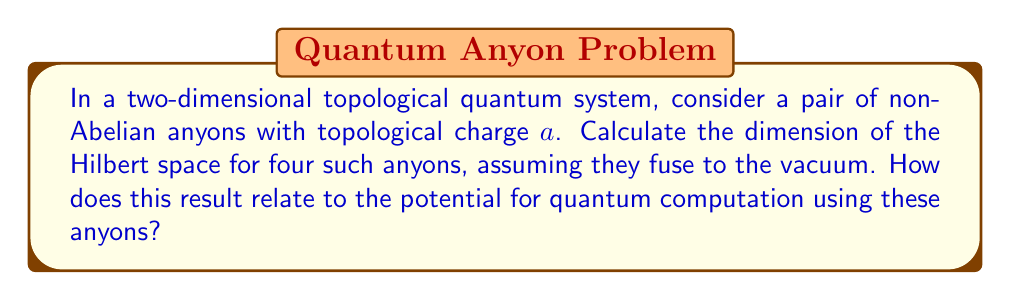Give your solution to this math problem. To solve this problem, we need to follow these steps:

1) First, recall that for non-Abelian anyons, the fusion outcome is not unique. For anyons with topological charge $a$, the fusion rules can be represented as:

   $$ a \times a = I + \psi $$

   where $I$ is the vacuum (trivial charge) and $\psi$ is some non-trivial charge.

2) For four anyons, we need to consider the different ways they can fuse. We can represent this process as a fusion tree:

   [asy]
   import geometry;

   size(200);
   
   dot("$a$", (0,0));
   dot("$a$", (1,0));
   dot("$a$", (2,0));
   dot("$a$", (3,0));
   
   draw((0,0)--(1.5,1.5));
   draw((1,0)--(1.5,1.5));
   draw((2,0)--(1.5,1.5));
   draw((3,0)--(1.5,1.5));
   
   label("$x$", (0.75,0.75));
   label("$y$", (2.25,0.75));
   label("$I$", (1.5,1.5));
   [/asy]

3) In this diagram, $x$ and $y$ represent intermediate fusion outcomes, which can be either $I$ or $\psi$.

4) The dimension of the Hilbert space is given by the number of distinct fusion paths that lead to the vacuum. We can count these:

   - If $x = I$ and $y = I$, there is 1 path
   - If $x = \psi$ and $y = \psi$, there is 1 path
   - If $x = I$ and $y = \psi$, there are 0 paths
   - If $x = \psi$ and $y = I$, there are 0 paths

5) Therefore, the total dimension of the Hilbert space is 2.

6) In terms of quantum computation, this result is significant because it demonstrates that these non-Abelian anyons can encode quantum information. The two-dimensional Hilbert space for four anyons can represent a qubit, the fundamental unit of quantum information.

7) Moreover, braiding operations on these anyons can implement unitary transformations on this qubit, allowing for topologically protected quantum gates. This protection arises from the topological nature of the braiding, which is resistant to local perturbations.
Answer: The dimension of the Hilbert space for four non-Abelian anyons with topological charge $a$, fusing to the vacuum, is 2. This two-dimensional space can encode a qubit, demonstrating the potential for topological quantum computation using these anyons. 